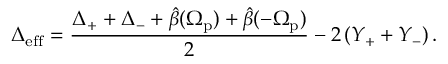Convert formula to latex. <formula><loc_0><loc_0><loc_500><loc_500>\Delta _ { e f f } = \frac { \Delta _ { + } + \Delta _ { - } + \hat { \beta } ( \Omega _ { p } ) + \hat { \beta } ( - \Omega _ { p } ) } { 2 } - 2 \left ( Y _ { + } + Y _ { - } \right ) .</formula> 